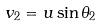<formula> <loc_0><loc_0><loc_500><loc_500>v _ { 2 } = u \sin \theta _ { 2 }</formula> 